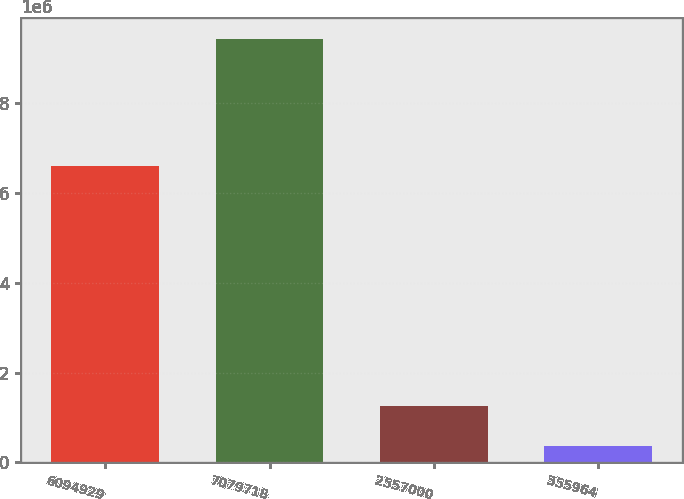Convert chart to OTSL. <chart><loc_0><loc_0><loc_500><loc_500><bar_chart><fcel>6094929<fcel>7079718<fcel>2557000<fcel>355964<nl><fcel>6.59397e+06<fcel>9.42339e+06<fcel>1.26547e+06<fcel>359034<nl></chart> 